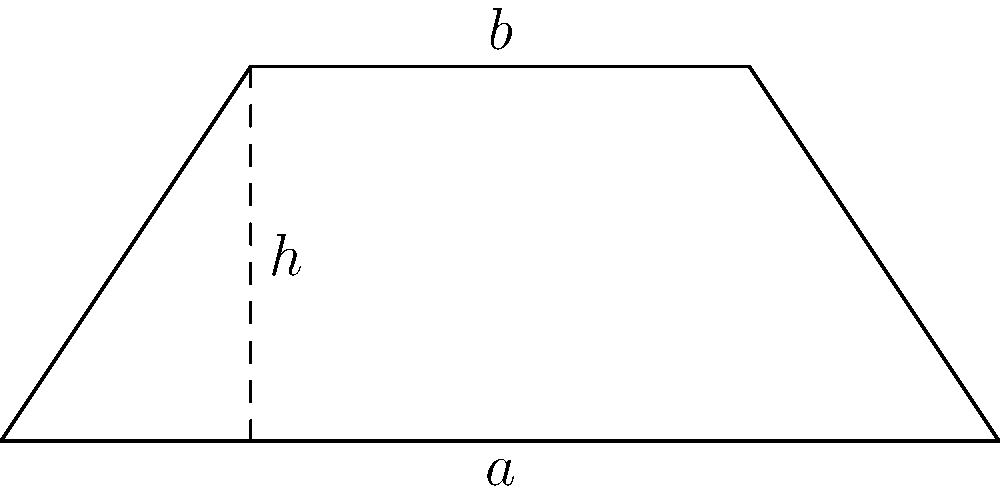Calculate the area of the trapezoid shown in the figure, where the parallel sides are $a = 8$ units and $b = 4$ units, and the height $h = 3$ units. To calculate the area of a trapezoid, we use the formula:

$$A = \frac{1}{2}(a+b)h$$

Where:
$A$ is the area
$a$ and $b$ are the lengths of the parallel sides
$h$ is the height

Let's substitute the given values:
$a = 8$ units
$b = 4$ units
$h = 3$ units

Now, let's solve step by step:

1) Substitute the values into the formula:
   $$A = \frac{1}{2}(8+4)(3)$$

2) Add the values inside the parentheses:
   $$A = \frac{1}{2}(12)(3)$$

3) Multiply:
   $$A = \frac{1}{2}(36)$$

4) Simplify:
   $$A = 18$$

Therefore, the area of the trapezoid is 18 square units.
Answer: 18 square units 